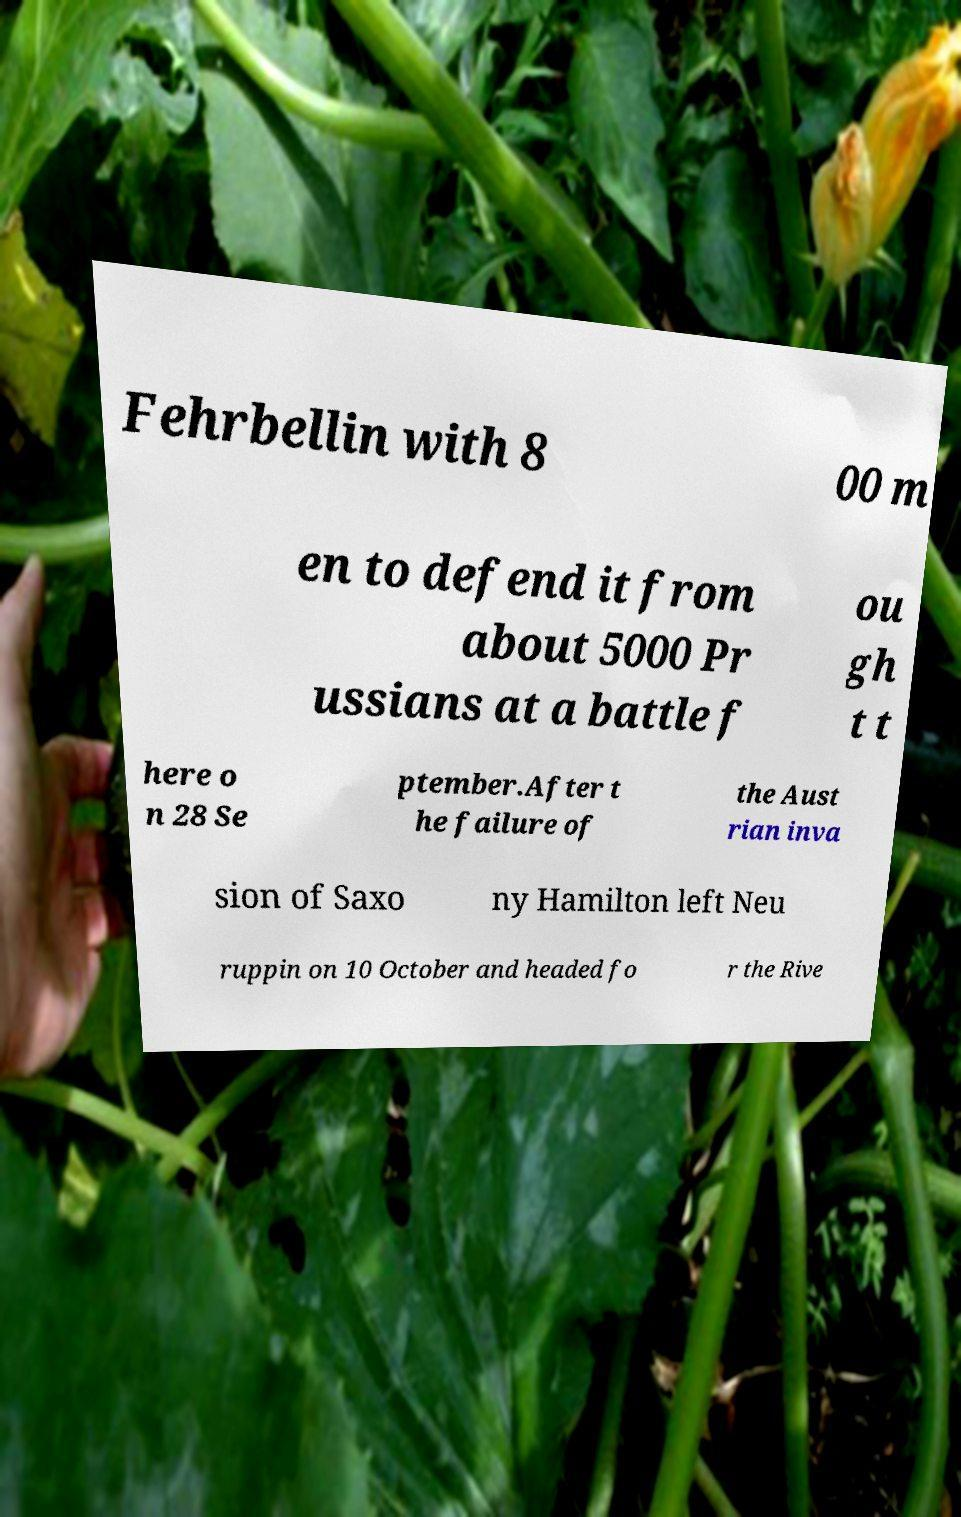I need the written content from this picture converted into text. Can you do that? Fehrbellin with 8 00 m en to defend it from about 5000 Pr ussians at a battle f ou gh t t here o n 28 Se ptember.After t he failure of the Aust rian inva sion of Saxo ny Hamilton left Neu ruppin on 10 October and headed fo r the Rive 